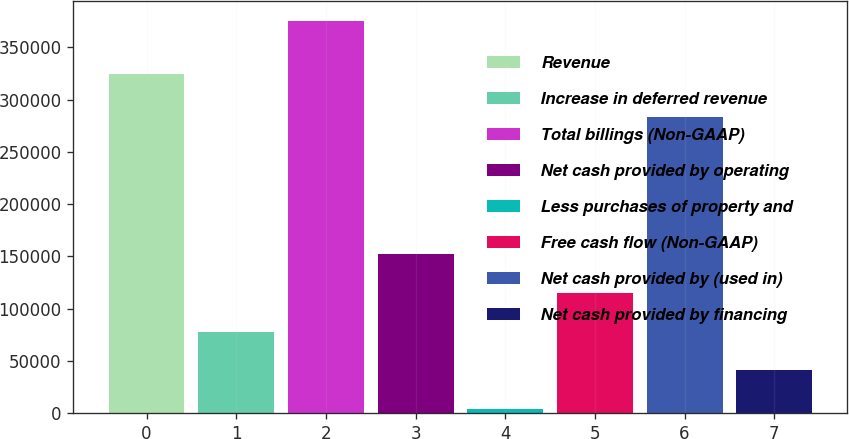Convert chart to OTSL. <chart><loc_0><loc_0><loc_500><loc_500><bar_chart><fcel>Revenue<fcel>Increase in deferred revenue<fcel>Total billings (Non-GAAP)<fcel>Net cash provided by operating<fcel>Less purchases of property and<fcel>Free cash flow (Non-GAAP)<fcel>Net cash provided by (used in)<fcel>Net cash provided by financing<nl><fcel>324696<fcel>78100.2<fcel>375397<fcel>152424<fcel>3776<fcel>115262<fcel>283710<fcel>40938.1<nl></chart> 